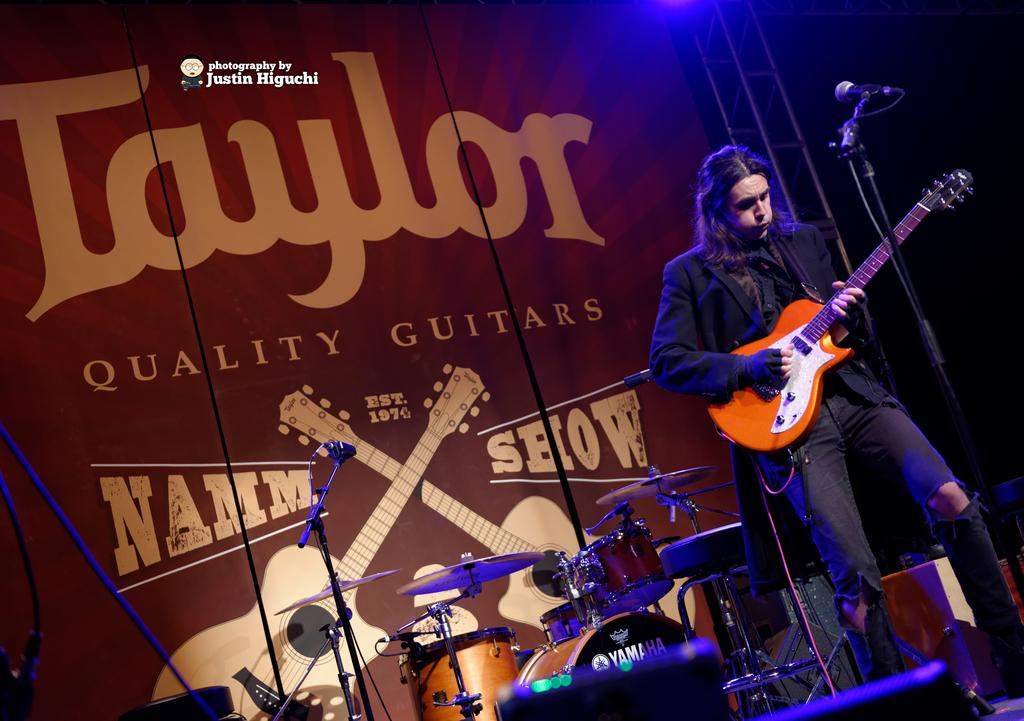What is the man in the image wearing? The man is wearing a black suit in the image. What is the man doing in the image? The man is playing a guitar in the image. What object is present for amplifying sound in the image? There is a microphone with a holder in the image. What other musical items can be seen in the image? There are musical instruments and a poster of a musical instrument in the image. How does the man show respect to the coast in the image? There is no mention of a coast in the image, so it is not possible to determine how the man might show respect to it. 